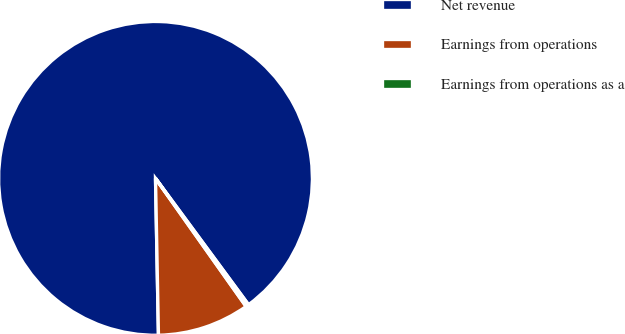<chart> <loc_0><loc_0><loc_500><loc_500><pie_chart><fcel>Net revenue<fcel>Earnings from operations<fcel>Earnings from operations as a<nl><fcel>90.2%<fcel>9.5%<fcel>0.3%<nl></chart> 